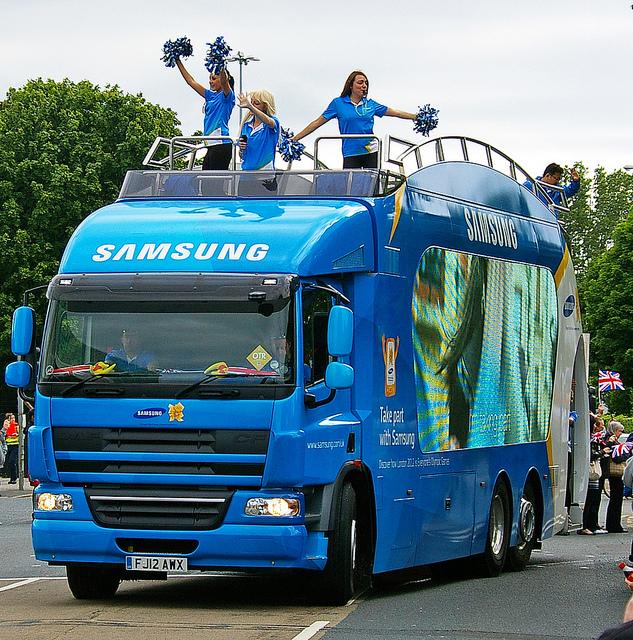What word is on the front of the bus?
Write a very short answer. Samsung. What are the girls holding in their hands?
Be succinct. Pom poms. What country are they in?
Short answer required. England. 